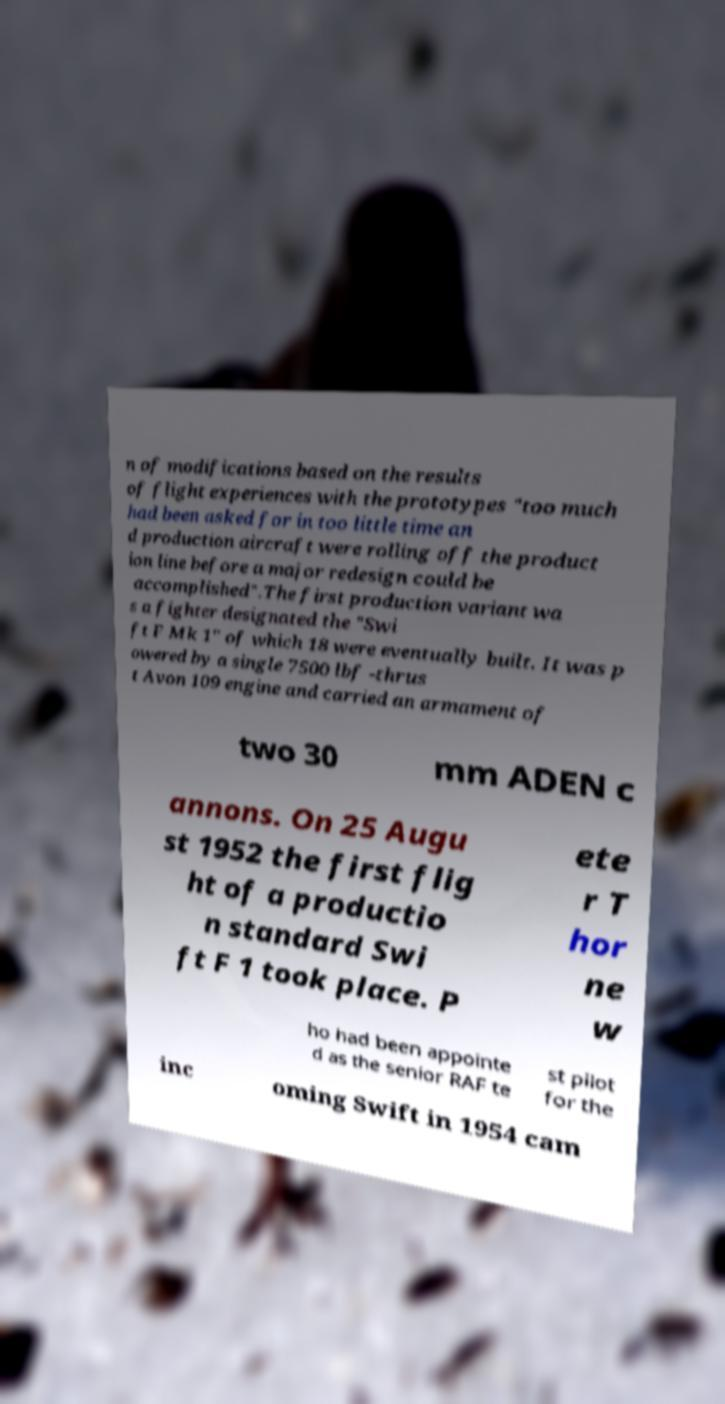Please identify and transcribe the text found in this image. n of modifications based on the results of flight experiences with the prototypes "too much had been asked for in too little time an d production aircraft were rolling off the product ion line before a major redesign could be accomplished".The first production variant wa s a fighter designated the "Swi ft F Mk 1" of which 18 were eventually built. It was p owered by a single 7500 lbf -thrus t Avon 109 engine and carried an armament of two 30 mm ADEN c annons. On 25 Augu st 1952 the first flig ht of a productio n standard Swi ft F 1 took place. P ete r T hor ne w ho had been appointe d as the senior RAF te st pilot for the inc oming Swift in 1954 cam 